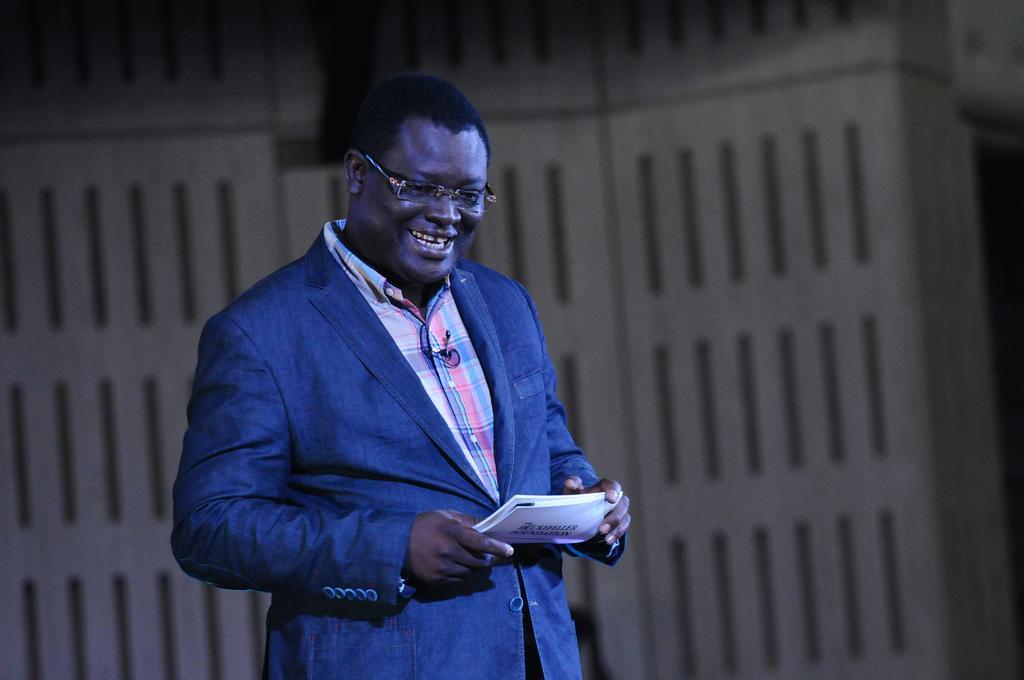How would you summarize this image in a sentence or two? In this image we can see a man holding paper. Behind the man we can see a white object looks like a wall. 